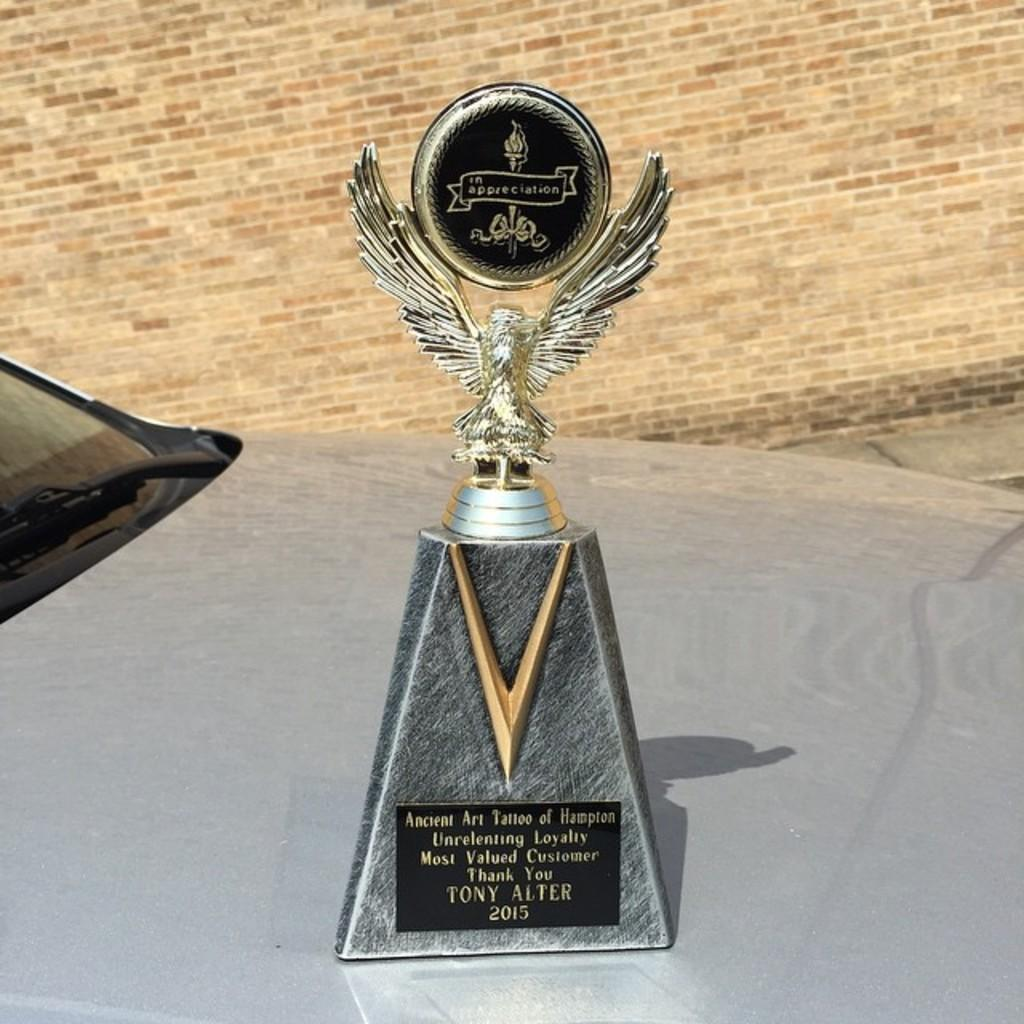<image>
Write a terse but informative summary of the picture. A most valued customer award given to Tony Alter in 2015. 